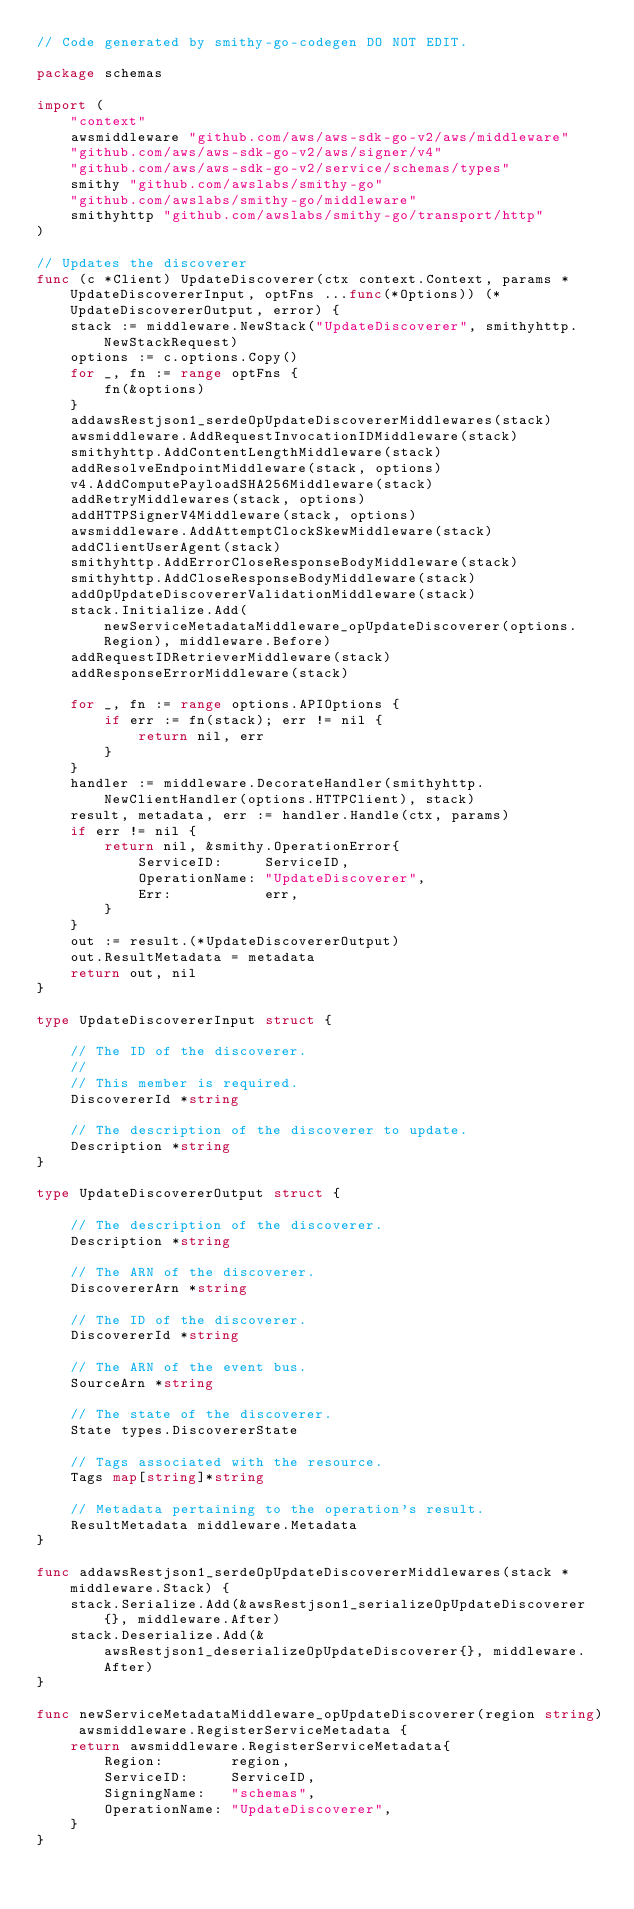Convert code to text. <code><loc_0><loc_0><loc_500><loc_500><_Go_>// Code generated by smithy-go-codegen DO NOT EDIT.

package schemas

import (
	"context"
	awsmiddleware "github.com/aws/aws-sdk-go-v2/aws/middleware"
	"github.com/aws/aws-sdk-go-v2/aws/signer/v4"
	"github.com/aws/aws-sdk-go-v2/service/schemas/types"
	smithy "github.com/awslabs/smithy-go"
	"github.com/awslabs/smithy-go/middleware"
	smithyhttp "github.com/awslabs/smithy-go/transport/http"
)

// Updates the discoverer
func (c *Client) UpdateDiscoverer(ctx context.Context, params *UpdateDiscovererInput, optFns ...func(*Options)) (*UpdateDiscovererOutput, error) {
	stack := middleware.NewStack("UpdateDiscoverer", smithyhttp.NewStackRequest)
	options := c.options.Copy()
	for _, fn := range optFns {
		fn(&options)
	}
	addawsRestjson1_serdeOpUpdateDiscovererMiddlewares(stack)
	awsmiddleware.AddRequestInvocationIDMiddleware(stack)
	smithyhttp.AddContentLengthMiddleware(stack)
	addResolveEndpointMiddleware(stack, options)
	v4.AddComputePayloadSHA256Middleware(stack)
	addRetryMiddlewares(stack, options)
	addHTTPSignerV4Middleware(stack, options)
	awsmiddleware.AddAttemptClockSkewMiddleware(stack)
	addClientUserAgent(stack)
	smithyhttp.AddErrorCloseResponseBodyMiddleware(stack)
	smithyhttp.AddCloseResponseBodyMiddleware(stack)
	addOpUpdateDiscovererValidationMiddleware(stack)
	stack.Initialize.Add(newServiceMetadataMiddleware_opUpdateDiscoverer(options.Region), middleware.Before)
	addRequestIDRetrieverMiddleware(stack)
	addResponseErrorMiddleware(stack)

	for _, fn := range options.APIOptions {
		if err := fn(stack); err != nil {
			return nil, err
		}
	}
	handler := middleware.DecorateHandler(smithyhttp.NewClientHandler(options.HTTPClient), stack)
	result, metadata, err := handler.Handle(ctx, params)
	if err != nil {
		return nil, &smithy.OperationError{
			ServiceID:     ServiceID,
			OperationName: "UpdateDiscoverer",
			Err:           err,
		}
	}
	out := result.(*UpdateDiscovererOutput)
	out.ResultMetadata = metadata
	return out, nil
}

type UpdateDiscovererInput struct {

	// The ID of the discoverer.
	//
	// This member is required.
	DiscovererId *string

	// The description of the discoverer to update.
	Description *string
}

type UpdateDiscovererOutput struct {

	// The description of the discoverer.
	Description *string

	// The ARN of the discoverer.
	DiscovererArn *string

	// The ID of the discoverer.
	DiscovererId *string

	// The ARN of the event bus.
	SourceArn *string

	// The state of the discoverer.
	State types.DiscovererState

	// Tags associated with the resource.
	Tags map[string]*string

	// Metadata pertaining to the operation's result.
	ResultMetadata middleware.Metadata
}

func addawsRestjson1_serdeOpUpdateDiscovererMiddlewares(stack *middleware.Stack) {
	stack.Serialize.Add(&awsRestjson1_serializeOpUpdateDiscoverer{}, middleware.After)
	stack.Deserialize.Add(&awsRestjson1_deserializeOpUpdateDiscoverer{}, middleware.After)
}

func newServiceMetadataMiddleware_opUpdateDiscoverer(region string) awsmiddleware.RegisterServiceMetadata {
	return awsmiddleware.RegisterServiceMetadata{
		Region:        region,
		ServiceID:     ServiceID,
		SigningName:   "schemas",
		OperationName: "UpdateDiscoverer",
	}
}
</code> 